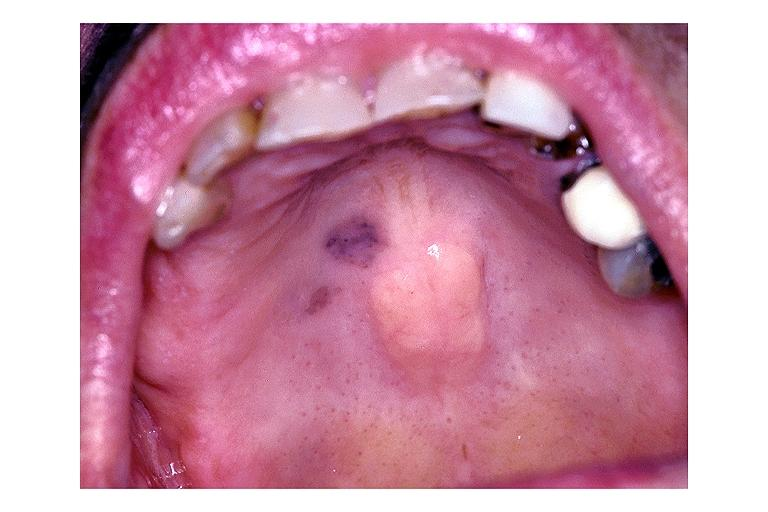does penis show focal melanosis?
Answer the question using a single word or phrase. No 